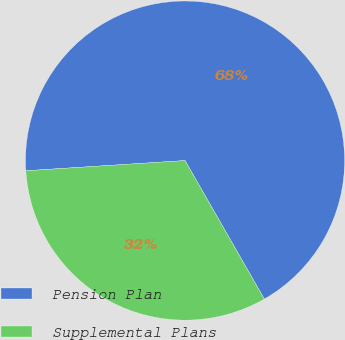Convert chart to OTSL. <chart><loc_0><loc_0><loc_500><loc_500><pie_chart><fcel>Pension Plan<fcel>Supplemental Plans<nl><fcel>67.74%<fcel>32.26%<nl></chart> 